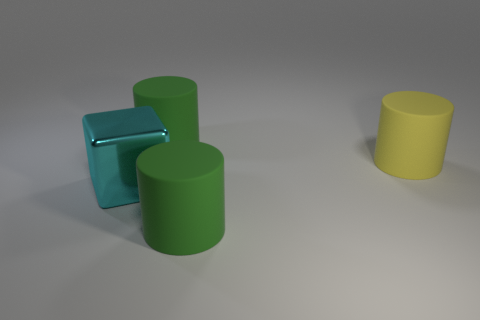Subtract all yellow cylinders. How many cylinders are left? 2 Subtract all yellow cylinders. How many cylinders are left? 2 Subtract 3 cylinders. How many cylinders are left? 0 Add 4 cyan shiny cubes. How many cyan shiny cubes exist? 5 Add 2 large cyan shiny objects. How many objects exist? 6 Subtract 0 red cylinders. How many objects are left? 4 Subtract all cylinders. How many objects are left? 1 Subtract all purple blocks. Subtract all yellow spheres. How many blocks are left? 1 Subtract all brown cylinders. How many brown blocks are left? 0 Subtract all metallic objects. Subtract all large cyan shiny objects. How many objects are left? 2 